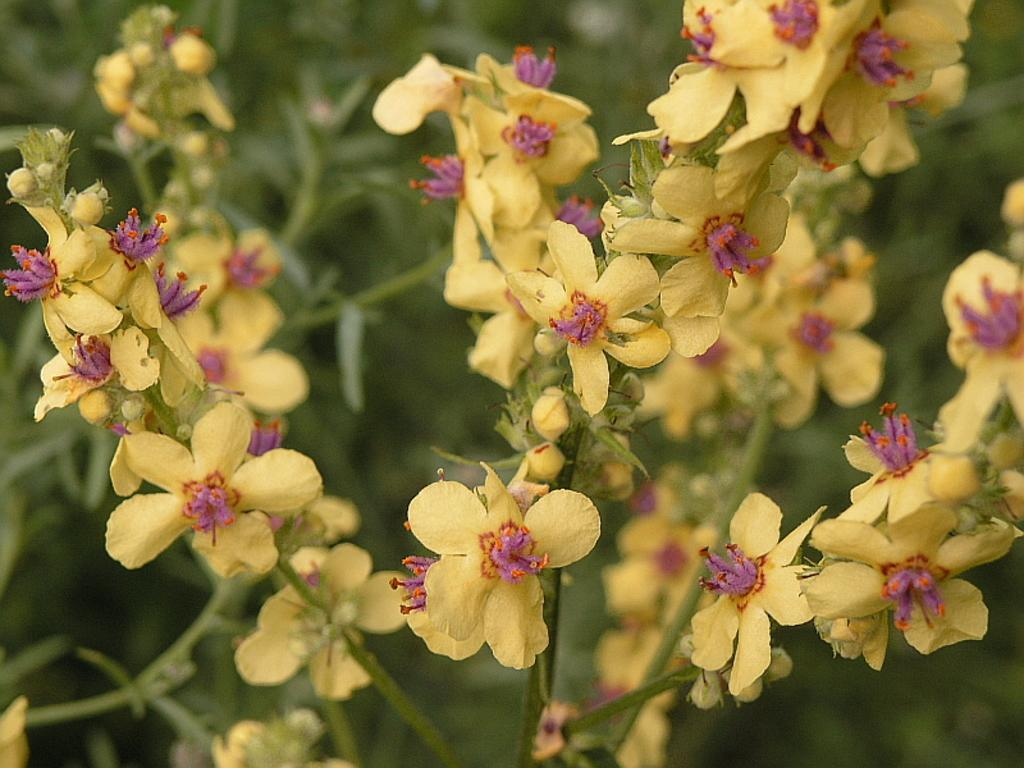What type of flora can be seen in the foreground of the image? There are flowers in the foreground of the image. What type of flora can be seen in the background of the image? There are plants in the background of the image. What is the weight of the plough in the image? There is no plough present in the image, so it is not possible to determine its weight. 